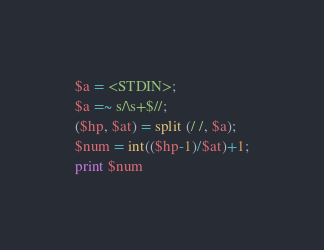<code> <loc_0><loc_0><loc_500><loc_500><_Perl_>$a = <STDIN>;
$a =~ s/\s+$//;
($hp, $at) = split (/ /, $a);
$num = int(($hp-1)/$at)+1;
print $num</code> 